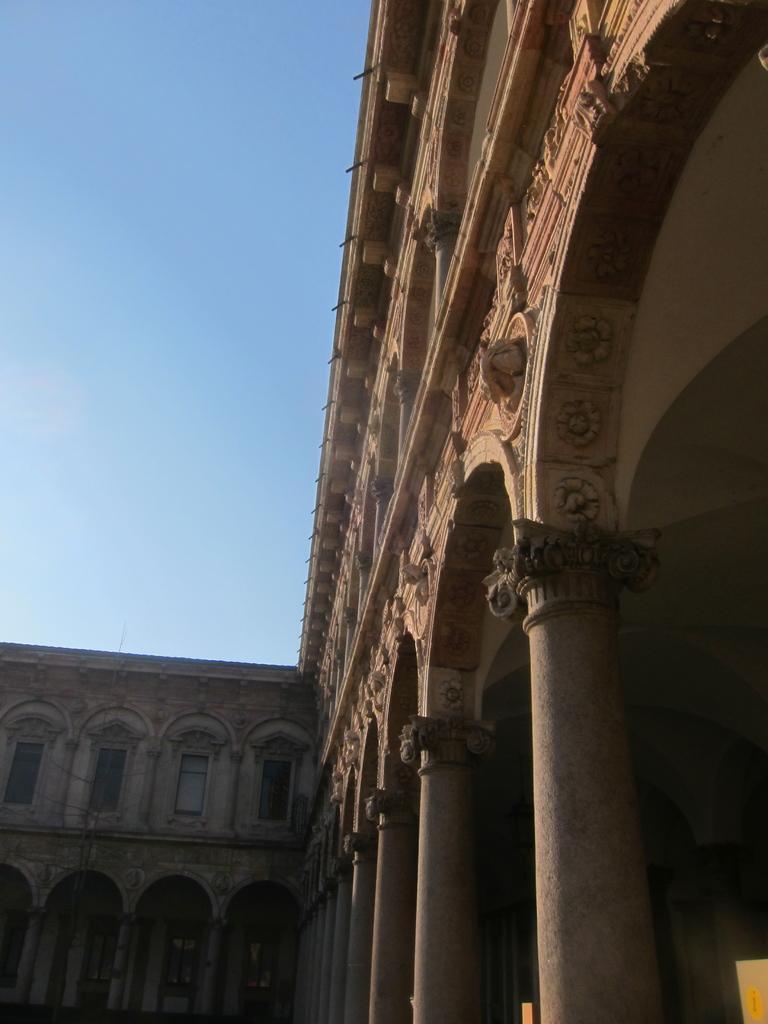How would you summarize this image in a sentence or two? A building with windows. These are pillars. Sky is in blue color. 